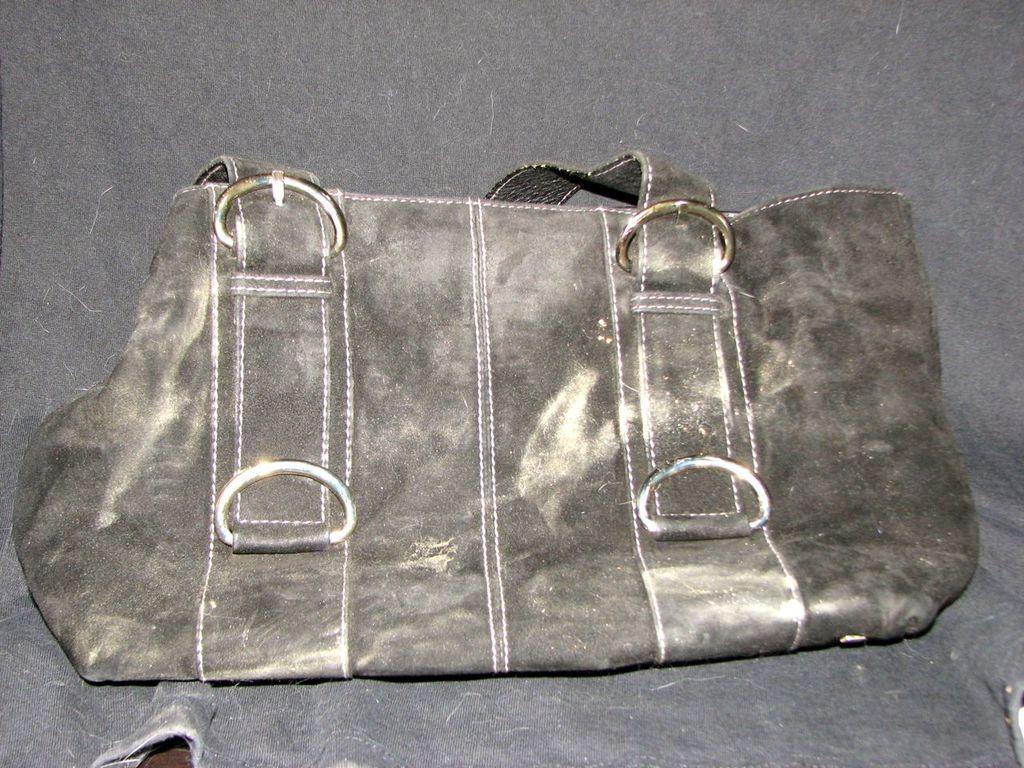Describe this image in one or two sentences. In this image i can see a bag. 